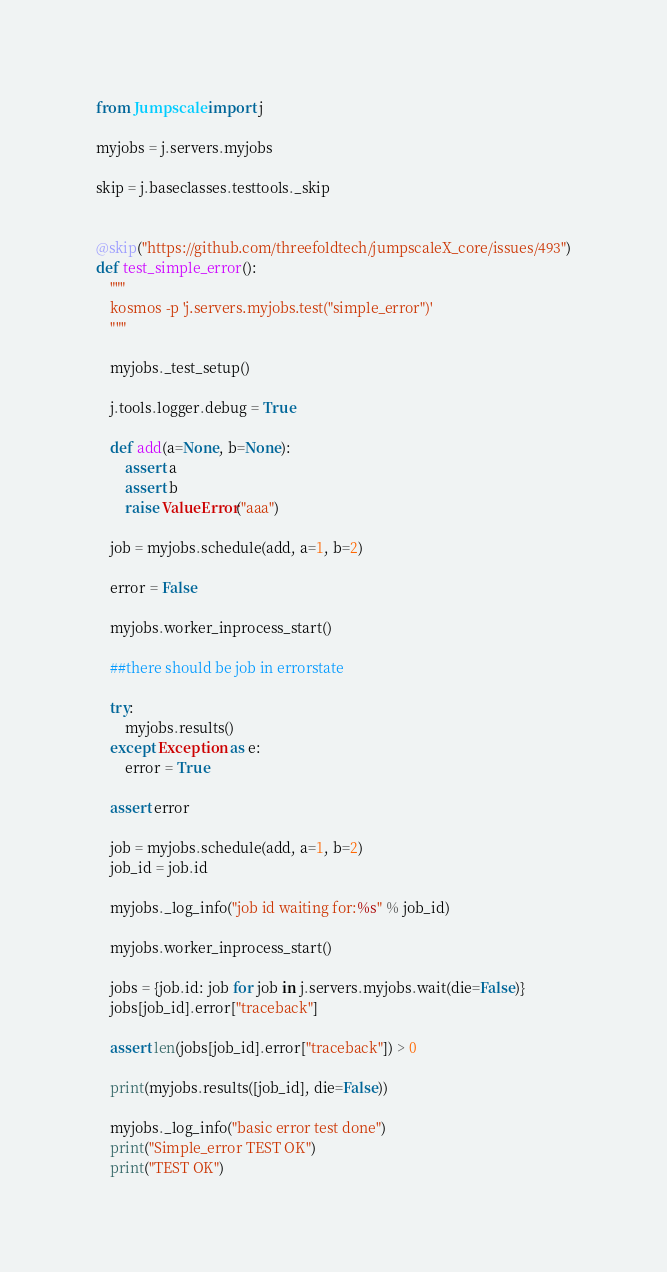Convert code to text. <code><loc_0><loc_0><loc_500><loc_500><_Python_>from Jumpscale import j

myjobs = j.servers.myjobs

skip = j.baseclasses.testtools._skip


@skip("https://github.com/threefoldtech/jumpscaleX_core/issues/493")
def test_simple_error():
    """
    kosmos -p 'j.servers.myjobs.test("simple_error")'
    """

    myjobs._test_setup()

    j.tools.logger.debug = True

    def add(a=None, b=None):
        assert a
        assert b
        raise ValueError("aaa")

    job = myjobs.schedule(add, a=1, b=2)

    error = False

    myjobs.worker_inprocess_start()

    ##there should be job in errorstate

    try:
        myjobs.results()
    except Exception as e:
        error = True

    assert error

    job = myjobs.schedule(add, a=1, b=2)
    job_id = job.id

    myjobs._log_info("job id waiting for:%s" % job_id)

    myjobs.worker_inprocess_start()

    jobs = {job.id: job for job in j.servers.myjobs.wait(die=False)}
    jobs[job_id].error["traceback"]

    assert len(jobs[job_id].error["traceback"]) > 0

    print(myjobs.results([job_id], die=False))

    myjobs._log_info("basic error test done")
    print("Simple_error TEST OK")
    print("TEST OK")
</code> 